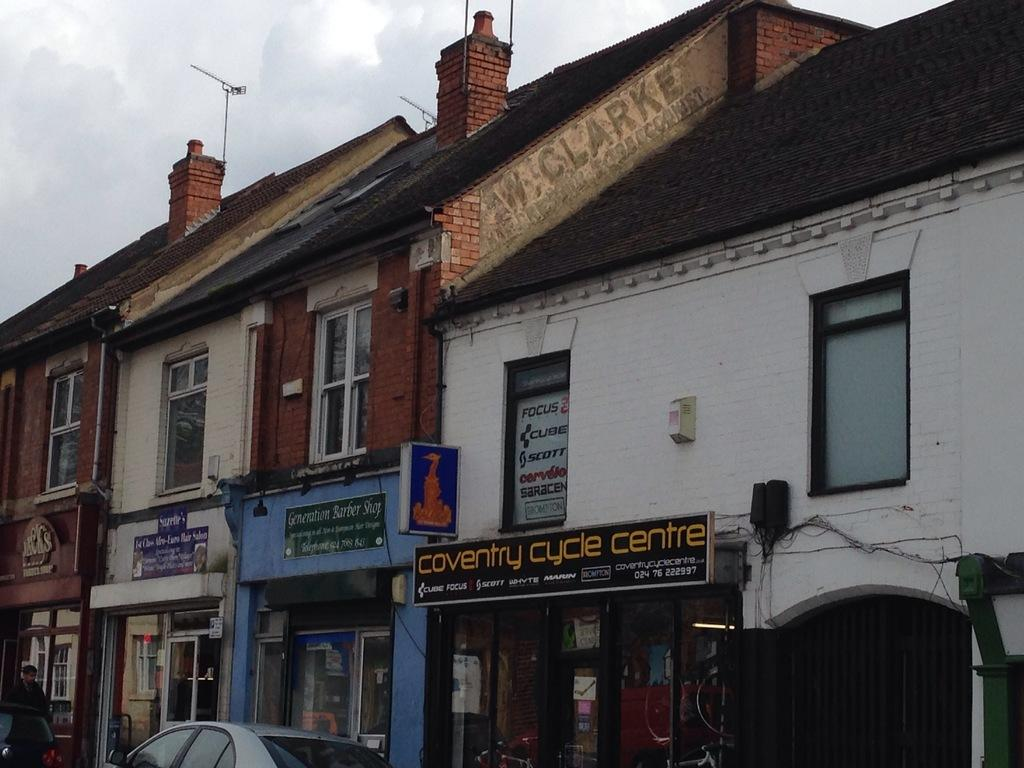What is located in the foreground of the picture? There is a board, cables, a car, and a person in the foreground of the picture. What can be seen in the middle of the picture? There are buildings in the middle of the picture. What is present at the top of the picture? There are antennas and the sky visible at the top of the picture. What type of part is the person holding in anger during dinner in the image? There is no dinner, anger, or part present in the image. The person is not holding anything, and there is no indication of anger or a dinner setting. 